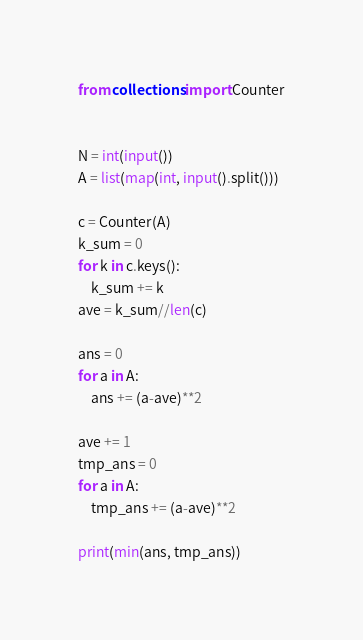<code> <loc_0><loc_0><loc_500><loc_500><_Python_>from collections import Counter


N = int(input())
A = list(map(int, input().split()))

c = Counter(A)
k_sum = 0
for k in c.keys():
    k_sum += k
ave = k_sum//len(c)

ans = 0
for a in A:
    ans += (a-ave)**2

ave += 1
tmp_ans = 0
for a in A:
    tmp_ans += (a-ave)**2

print(min(ans, tmp_ans))
</code> 